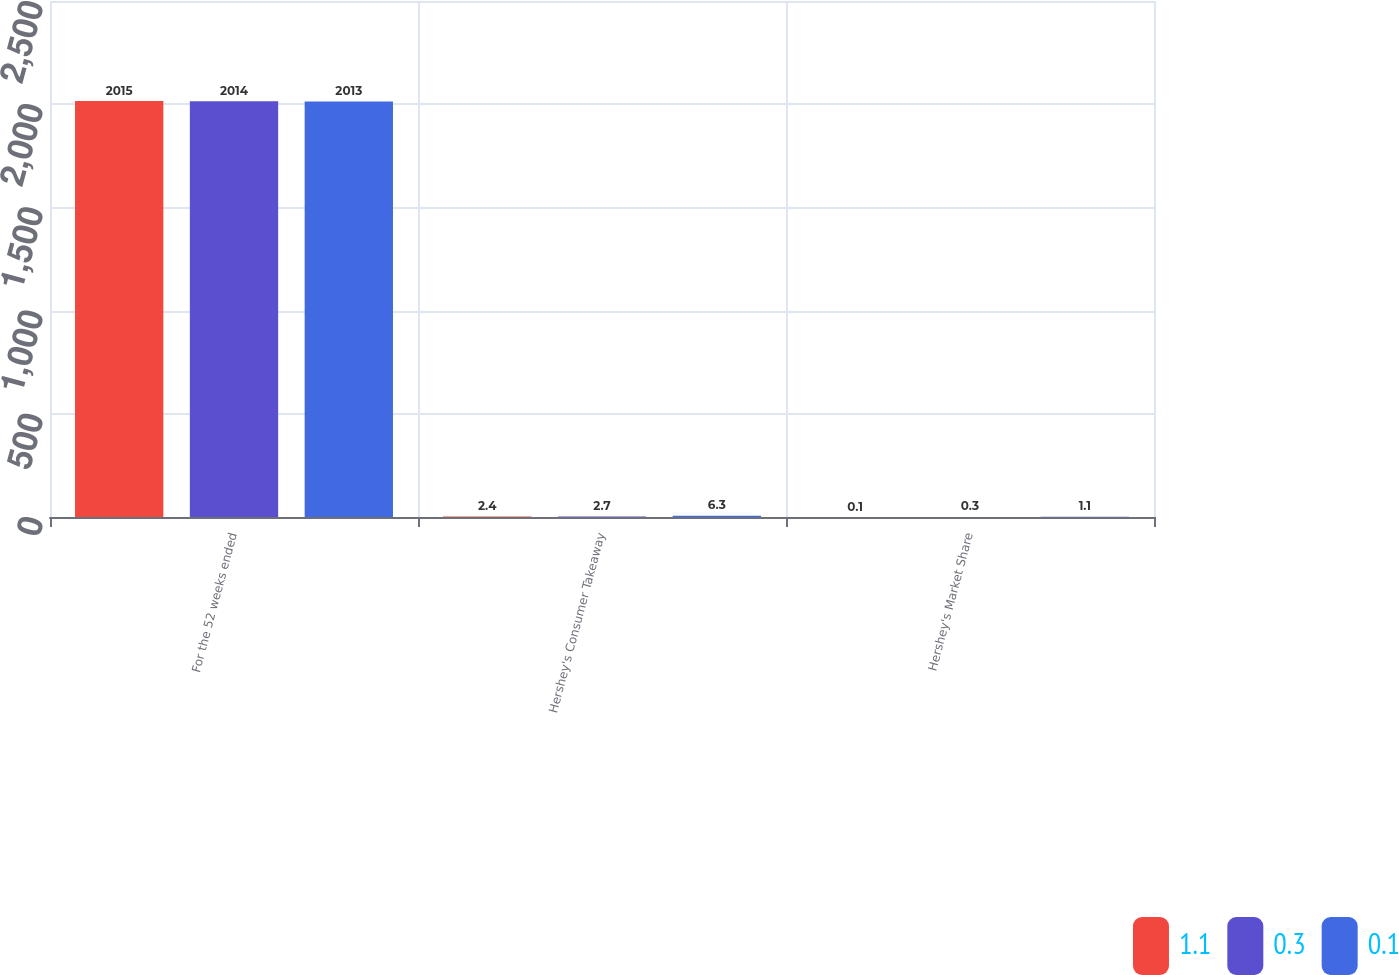Convert chart to OTSL. <chart><loc_0><loc_0><loc_500><loc_500><stacked_bar_chart><ecel><fcel>For the 52 weeks ended<fcel>Hershey's Consumer Takeaway<fcel>Hershey's Market Share<nl><fcel>1.1<fcel>2015<fcel>2.4<fcel>0.1<nl><fcel>0.3<fcel>2014<fcel>2.7<fcel>0.3<nl><fcel>0.1<fcel>2013<fcel>6.3<fcel>1.1<nl></chart> 